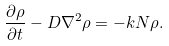Convert formula to latex. <formula><loc_0><loc_0><loc_500><loc_500>\frac { \partial \rho } { \partial t } - D \nabla ^ { 2 } \rho = - k N \rho .</formula> 